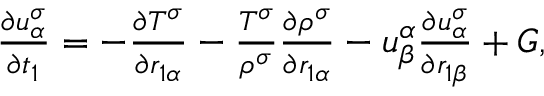<formula> <loc_0><loc_0><loc_500><loc_500>\begin{array} { r } { \begin{array} { r } { \frac { \partial u _ { \alpha } ^ { \sigma } } { \partial t _ { 1 } } = - \frac { \partial T ^ { \sigma } } { \partial r _ { 1 \alpha } } - \frac { T ^ { \sigma } } { \rho ^ { \sigma } } \frac { \partial \rho ^ { \sigma } } { \partial r _ { 1 \alpha } } - u _ { \beta } ^ { \alpha } \frac { \partial u _ { \alpha } ^ { \sigma } } { \partial r _ { 1 \beta } } + G , } \end{array} } \end{array}</formula> 